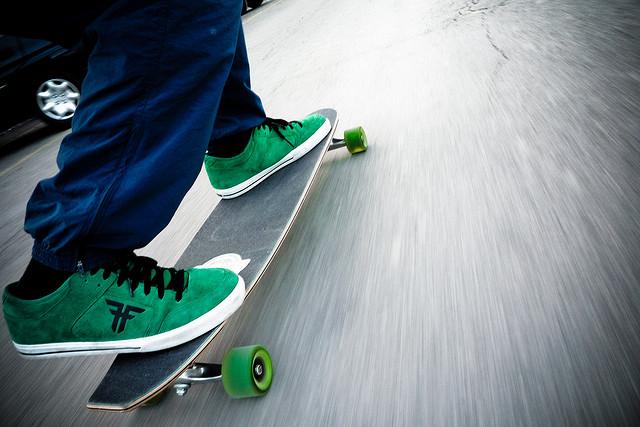What is the person doing?
Be succinct. Skateboarding. Is the person skateboarding?
Quick response, please. Yes. What colors are this person's shoes?
Give a very brief answer. Green. 